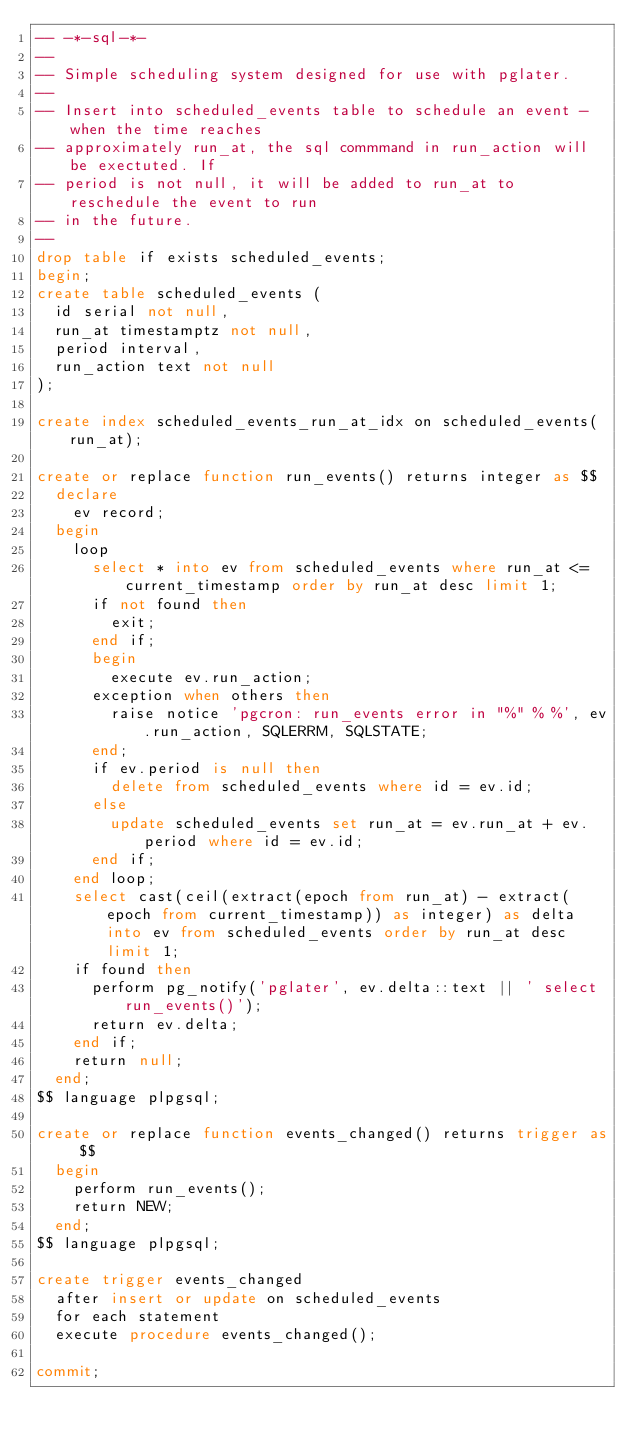<code> <loc_0><loc_0><loc_500><loc_500><_SQL_>-- -*-sql-*-
--
-- Simple scheduling system designed for use with pglater.
--
-- Insert into scheduled_events table to schedule an event - when the time reaches
-- approximately run_at, the sql commmand in run_action will be exectuted. If
-- period is not null, it will be added to run_at to reschedule the event to run
-- in the future.
--
drop table if exists scheduled_events;
begin;
create table scheduled_events (
  id serial not null,
  run_at timestamptz not null,
  period interval,
  run_action text not null
);

create index scheduled_events_run_at_idx on scheduled_events(run_at);

create or replace function run_events() returns integer as $$
  declare
    ev record;
  begin
    loop
      select * into ev from scheduled_events where run_at <= current_timestamp order by run_at desc limit 1;
      if not found then
        exit;
      end if;
      begin
        execute ev.run_action;
      exception when others then
        raise notice 'pgcron: run_events error in "%" % %', ev.run_action, SQLERRM, SQLSTATE;
      end;
      if ev.period is null then
        delete from scheduled_events where id = ev.id;
      else
        update scheduled_events set run_at = ev.run_at + ev.period where id = ev.id;
      end if;
    end loop;
    select cast(ceil(extract(epoch from run_at) - extract(epoch from current_timestamp)) as integer) as delta into ev from scheduled_events order by run_at desc limit 1;
    if found then
      perform pg_notify('pglater', ev.delta::text || ' select run_events()');
      return ev.delta;
    end if;
    return null;
  end;
$$ language plpgsql;

create or replace function events_changed() returns trigger as $$
  begin
    perform run_events();
    return NEW;
  end;
$$ language plpgsql;

create trigger events_changed
  after insert or update on scheduled_events
  for each statement
  execute procedure events_changed();

commit;
</code> 